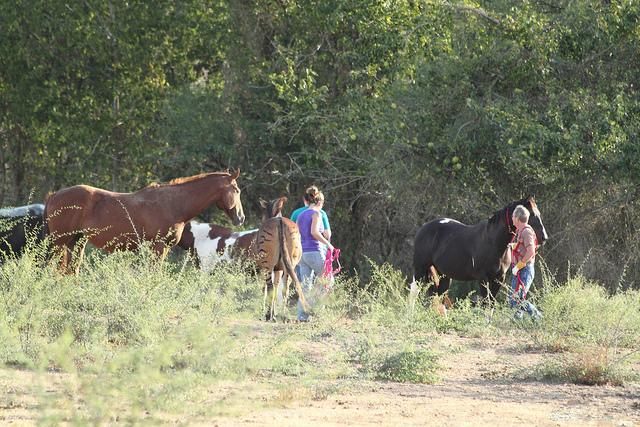What is the man on the far right carrying?
Answer briefly. Reins. What are the horses doing?
Keep it brief. Walking. Does this grass look very lush?
Answer briefly. No. Is this an animal farm?
Be succinct. Yes. 